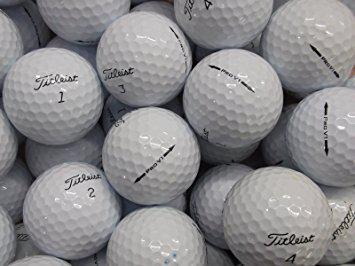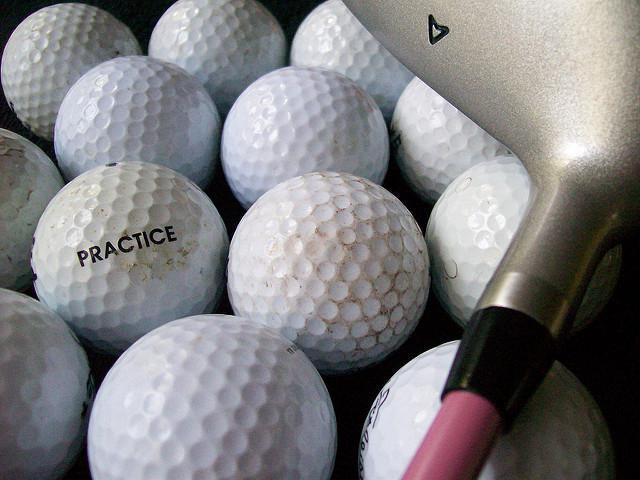The first image is the image on the left, the second image is the image on the right. Analyze the images presented: Is the assertion "Images show only white balls, and no image contains a golf club." valid? Answer yes or no. No. The first image is the image on the left, the second image is the image on the right. Assess this claim about the two images: "There is visible dirt on at least three golf balls.". Correct or not? Answer yes or no. Yes. 